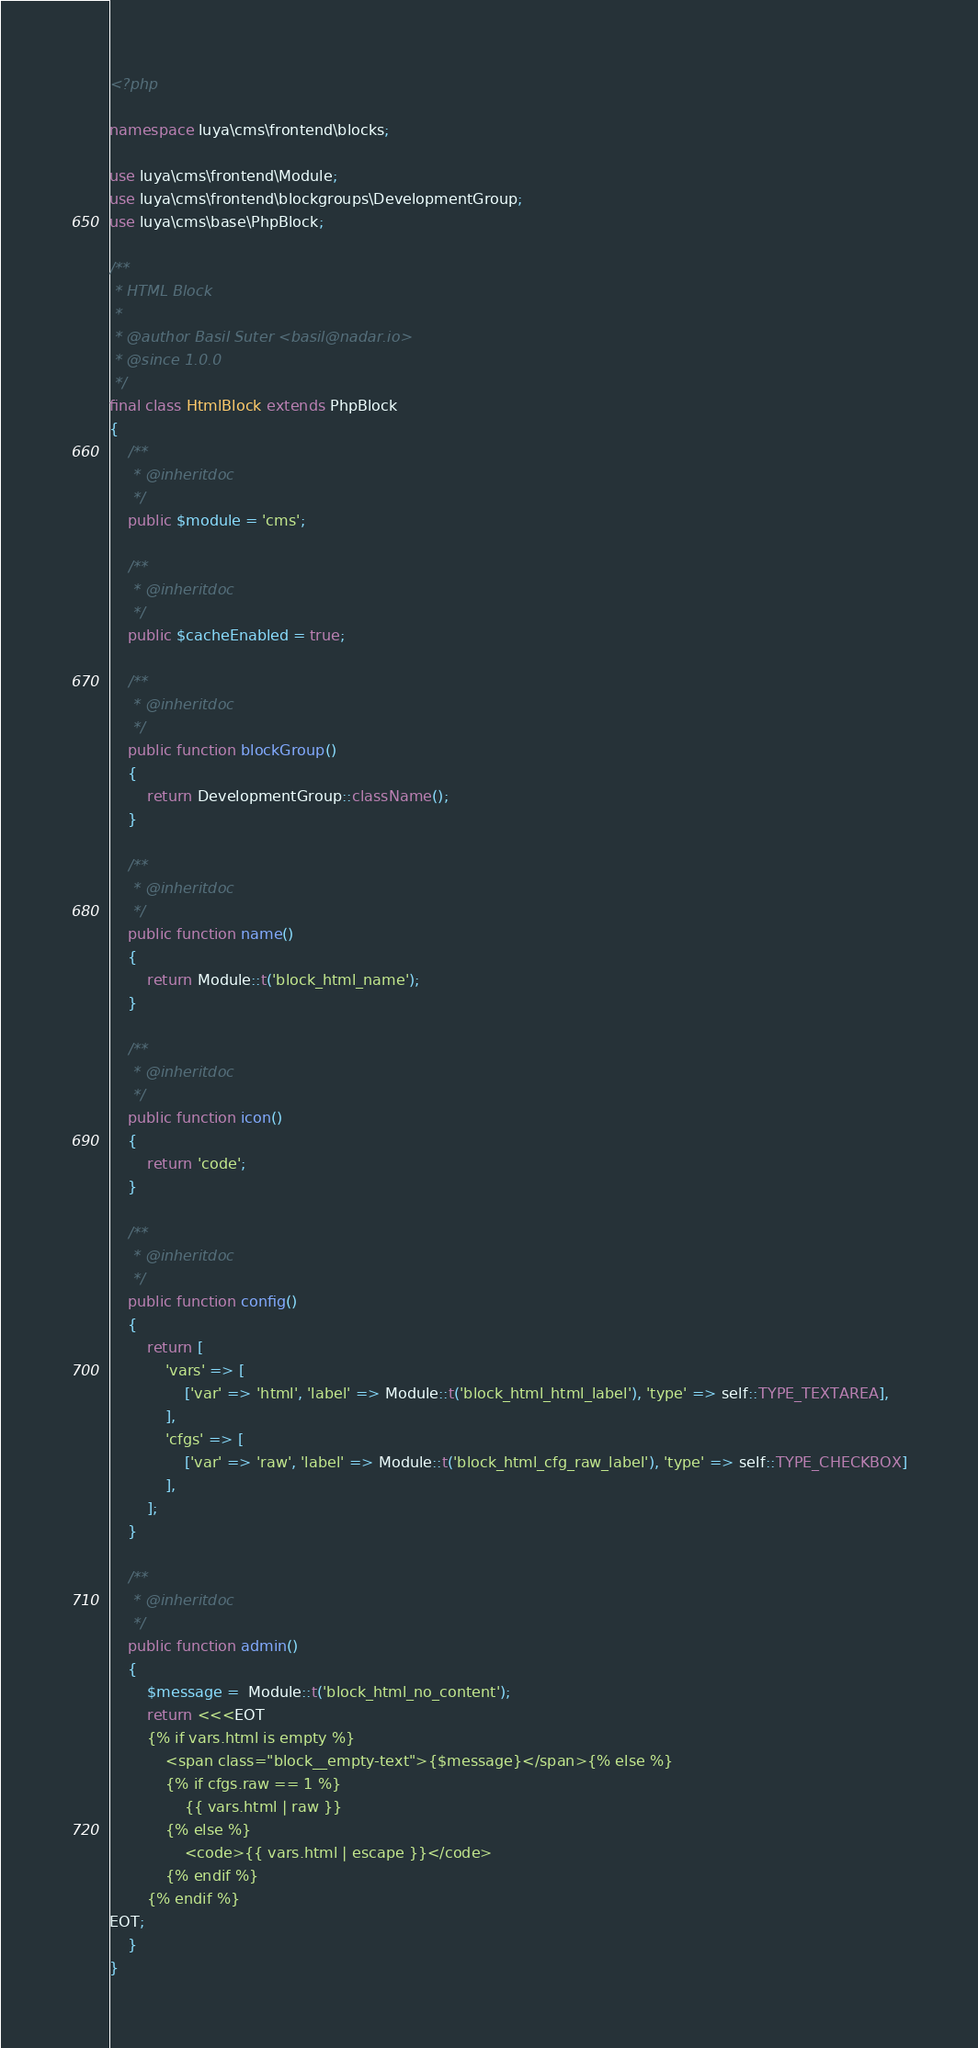<code> <loc_0><loc_0><loc_500><loc_500><_PHP_><?php

namespace luya\cms\frontend\blocks;

use luya\cms\frontend\Module;
use luya\cms\frontend\blockgroups\DevelopmentGroup;
use luya\cms\base\PhpBlock;

/**
 * HTML Block
 *
 * @author Basil Suter <basil@nadar.io>
 * @since 1.0.0
 */
final class HtmlBlock extends PhpBlock
{
    /**
     * @inheritdoc
     */
    public $module = 'cms';

    /**
     * @inheritdoc
     */
    public $cacheEnabled = true;

    /**
     * @inheritdoc
     */
    public function blockGroup()
    {
        return DevelopmentGroup::className();
    }
    
    /**
     * @inheritdoc
     */
    public function name()
    {
        return Module::t('block_html_name');
    }
    
    /**
     * @inheritdoc
     */
    public function icon()
    {
        return 'code';
    }

    /**
     * @inheritdoc
     */
    public function config()
    {
        return [
            'vars' => [
                ['var' => 'html', 'label' => Module::t('block_html_html_label'), 'type' => self::TYPE_TEXTAREA],
            ],
            'cfgs' => [
                ['var' => 'raw', 'label' => Module::t('block_html_cfg_raw_label'), 'type' => self::TYPE_CHECKBOX]
            ],
        ];
    }

    /**
     * @inheritdoc
     */
    public function admin()
    {
        $message =  Module::t('block_html_no_content');
        return <<<EOT
    	{% if vars.html is empty %}
    		<span class="block__empty-text">{$message}</span>{% else %}
    		{% if cfgs.raw == 1 %}
    			{{ vars.html | raw }}
    		{% else %}
                <code>{{ vars.html | escape }}</code>
    		{% endif %}
    	{% endif %}
EOT;
    }
}
</code> 